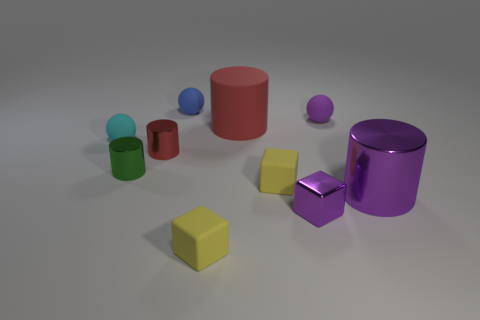Is there anything else that has the same color as the big matte object?
Offer a very short reply. Yes. What size is the yellow thing on the left side of the red cylinder that is on the right side of the small yellow matte block on the left side of the big matte cylinder?
Offer a very short reply. Small. The tiny matte sphere that is both to the left of the large red rubber object and on the right side of the green cylinder is what color?
Keep it short and to the point. Blue. What is the size of the cylinder that is on the left side of the small red cylinder?
Your response must be concise. Small. How many yellow blocks have the same material as the cyan object?
Make the answer very short. 2. What is the shape of the small metal thing that is the same color as the large rubber cylinder?
Ensure brevity in your answer.  Cylinder. There is a rubber object left of the small blue matte thing; does it have the same shape as the large red thing?
Keep it short and to the point. No. The other large object that is made of the same material as the cyan thing is what color?
Your answer should be very brief. Red. There is a small metal thing right of the small yellow object that is left of the big red matte cylinder; are there any shiny objects to the right of it?
Provide a succinct answer. Yes. What shape is the big red thing?
Keep it short and to the point. Cylinder. 